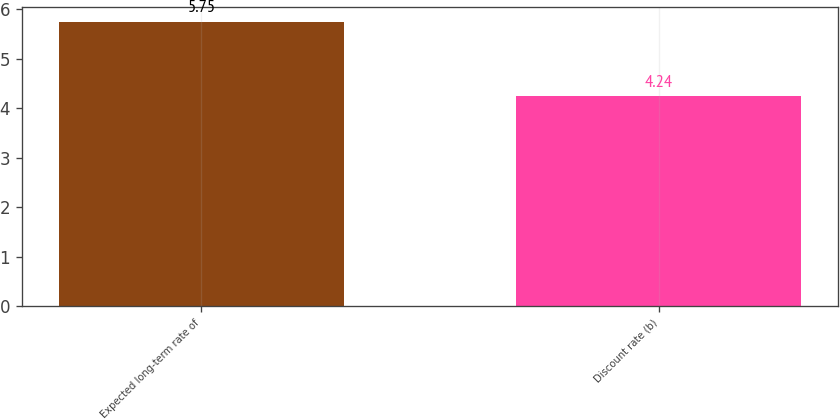<chart> <loc_0><loc_0><loc_500><loc_500><bar_chart><fcel>Expected long-term rate of<fcel>Discount rate (b)<nl><fcel>5.75<fcel>4.24<nl></chart> 